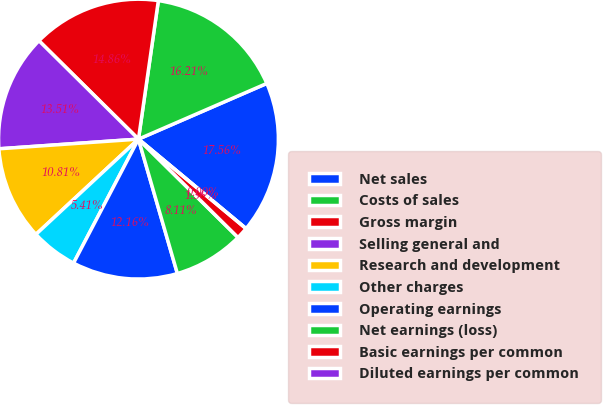Convert chart. <chart><loc_0><loc_0><loc_500><loc_500><pie_chart><fcel>Net sales<fcel>Costs of sales<fcel>Gross margin<fcel>Selling general and<fcel>Research and development<fcel>Other charges<fcel>Operating earnings<fcel>Net earnings (loss)<fcel>Basic earnings per common<fcel>Diluted earnings per common<nl><fcel>17.56%<fcel>16.21%<fcel>14.86%<fcel>13.51%<fcel>10.81%<fcel>5.41%<fcel>12.16%<fcel>8.11%<fcel>1.36%<fcel>0.0%<nl></chart> 